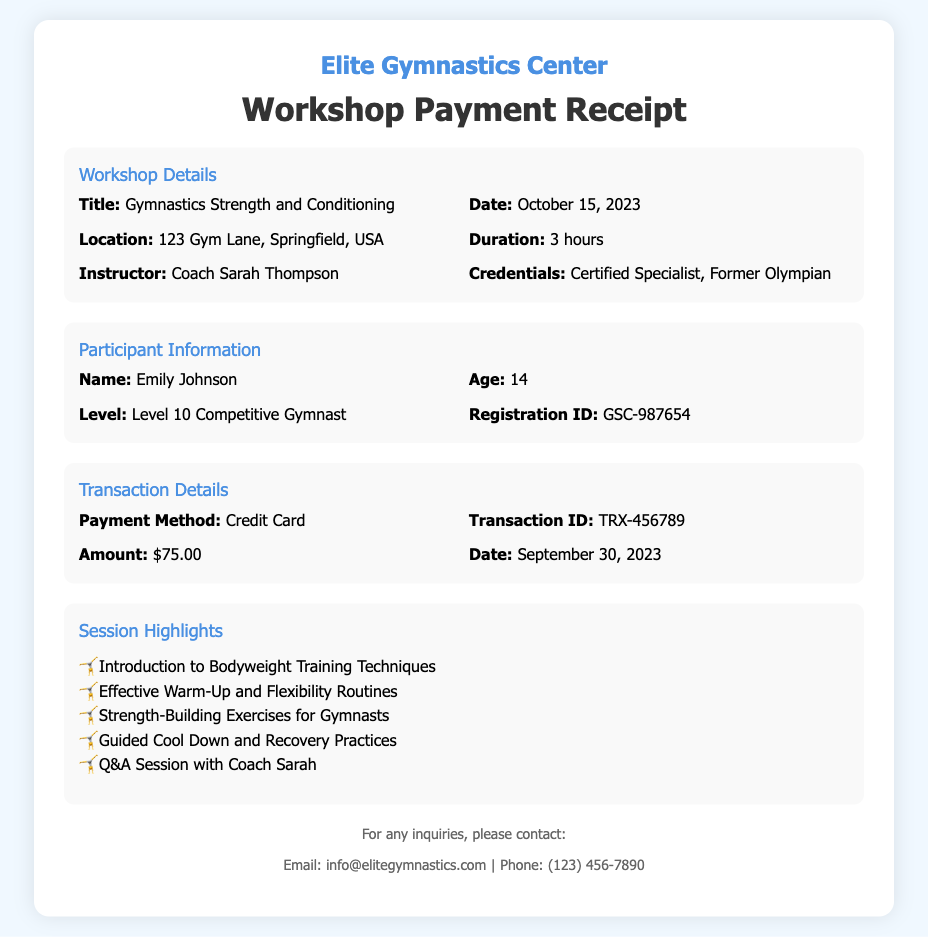what is the title of the workshop? The title of the workshop is given under the Workshop Details section in the document.
Answer: Gymnastics Strength and Conditioning who is the instructor of the workshop? The instructor's name is mentioned in the Workshop Details section.
Answer: Coach Sarah Thompson what is the date of the workshop? The date can be found in the Workshop Details section, which specifies when the event takes place.
Answer: October 15, 2023 how long is the duration of the workshop? The duration of the workshop is listed in the Workshop Details section of the document.
Answer: 3 hours what is the registration ID of the participant? The registration ID is provided in the Participant Information section of the document.
Answer: GSC-987654 what payment method was used for the transaction? The payment method is mentioned in the Transaction Details section.
Answer: Credit Card how much did the participant pay for the workshop? The amount paid is specified in the Transaction Details section.
Answer: $75.00 what are the session highlights focused on? The session highlights list specific focus points discussed during the workshop.
Answer: Bodyweight Training Techniques what is the age of the participant? The age of the participant is provided in the Participant Information section.
Answer: 14 